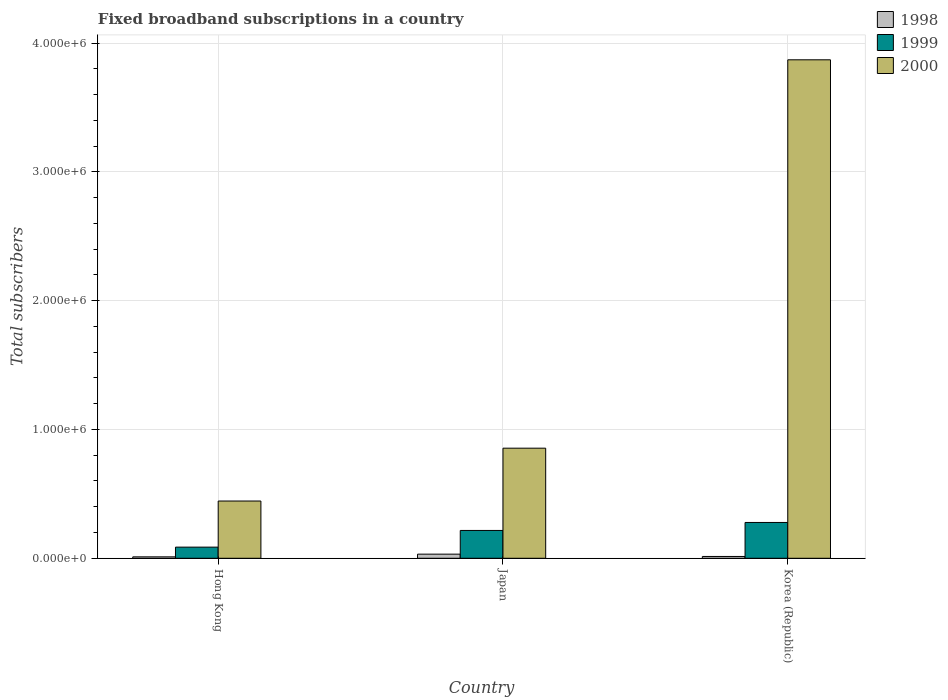How many different coloured bars are there?
Offer a very short reply. 3. Are the number of bars on each tick of the X-axis equal?
Provide a succinct answer. Yes. How many bars are there on the 2nd tick from the left?
Keep it short and to the point. 3. What is the label of the 2nd group of bars from the left?
Give a very brief answer. Japan. What is the number of broadband subscriptions in 1999 in Korea (Republic)?
Your answer should be very brief. 2.78e+05. Across all countries, what is the maximum number of broadband subscriptions in 1999?
Keep it short and to the point. 2.78e+05. Across all countries, what is the minimum number of broadband subscriptions in 2000?
Your answer should be compact. 4.44e+05. In which country was the number of broadband subscriptions in 1999 minimum?
Your answer should be very brief. Hong Kong. What is the total number of broadband subscriptions in 2000 in the graph?
Your answer should be very brief. 5.17e+06. What is the difference between the number of broadband subscriptions in 1999 in Hong Kong and that in Korea (Republic)?
Provide a short and direct response. -1.92e+05. What is the difference between the number of broadband subscriptions in 2000 in Japan and the number of broadband subscriptions in 1998 in Korea (Republic)?
Ensure brevity in your answer.  8.41e+05. What is the average number of broadband subscriptions in 2000 per country?
Provide a short and direct response. 1.72e+06. What is the difference between the number of broadband subscriptions of/in 1998 and number of broadband subscriptions of/in 1999 in Korea (Republic)?
Provide a succinct answer. -2.64e+05. In how many countries, is the number of broadband subscriptions in 1999 greater than 2200000?
Provide a succinct answer. 0. What is the ratio of the number of broadband subscriptions in 1999 in Hong Kong to that in Korea (Republic)?
Your answer should be very brief. 0.31. What is the difference between the highest and the second highest number of broadband subscriptions in 1999?
Your response must be concise. 1.92e+05. What is the difference between the highest and the lowest number of broadband subscriptions in 2000?
Make the answer very short. 3.43e+06. What does the 1st bar from the left in Korea (Republic) represents?
Give a very brief answer. 1998. How many bars are there?
Provide a short and direct response. 9. Are all the bars in the graph horizontal?
Your answer should be very brief. No. How many countries are there in the graph?
Your answer should be compact. 3. What is the difference between two consecutive major ticks on the Y-axis?
Offer a very short reply. 1.00e+06. Does the graph contain grids?
Keep it short and to the point. Yes. How many legend labels are there?
Your answer should be very brief. 3. What is the title of the graph?
Provide a short and direct response. Fixed broadband subscriptions in a country. Does "2010" appear as one of the legend labels in the graph?
Offer a very short reply. No. What is the label or title of the X-axis?
Ensure brevity in your answer.  Country. What is the label or title of the Y-axis?
Your response must be concise. Total subscribers. What is the Total subscribers in 1998 in Hong Kong?
Your answer should be compact. 1.10e+04. What is the Total subscribers of 1999 in Hong Kong?
Provide a succinct answer. 8.65e+04. What is the Total subscribers in 2000 in Hong Kong?
Give a very brief answer. 4.44e+05. What is the Total subscribers in 1998 in Japan?
Offer a terse response. 3.20e+04. What is the Total subscribers of 1999 in Japan?
Provide a short and direct response. 2.16e+05. What is the Total subscribers in 2000 in Japan?
Keep it short and to the point. 8.55e+05. What is the Total subscribers in 1998 in Korea (Republic)?
Ensure brevity in your answer.  1.40e+04. What is the Total subscribers in 1999 in Korea (Republic)?
Provide a succinct answer. 2.78e+05. What is the Total subscribers in 2000 in Korea (Republic)?
Offer a terse response. 3.87e+06. Across all countries, what is the maximum Total subscribers in 1998?
Keep it short and to the point. 3.20e+04. Across all countries, what is the maximum Total subscribers of 1999?
Provide a succinct answer. 2.78e+05. Across all countries, what is the maximum Total subscribers in 2000?
Offer a terse response. 3.87e+06. Across all countries, what is the minimum Total subscribers of 1998?
Offer a very short reply. 1.10e+04. Across all countries, what is the minimum Total subscribers in 1999?
Make the answer very short. 8.65e+04. Across all countries, what is the minimum Total subscribers in 2000?
Ensure brevity in your answer.  4.44e+05. What is the total Total subscribers in 1998 in the graph?
Your answer should be compact. 5.70e+04. What is the total Total subscribers of 1999 in the graph?
Make the answer very short. 5.80e+05. What is the total Total subscribers in 2000 in the graph?
Your answer should be very brief. 5.17e+06. What is the difference between the Total subscribers in 1998 in Hong Kong and that in Japan?
Your answer should be compact. -2.10e+04. What is the difference between the Total subscribers of 1999 in Hong Kong and that in Japan?
Your answer should be very brief. -1.30e+05. What is the difference between the Total subscribers of 2000 in Hong Kong and that in Japan?
Your response must be concise. -4.10e+05. What is the difference between the Total subscribers in 1998 in Hong Kong and that in Korea (Republic)?
Ensure brevity in your answer.  -3000. What is the difference between the Total subscribers of 1999 in Hong Kong and that in Korea (Republic)?
Your response must be concise. -1.92e+05. What is the difference between the Total subscribers of 2000 in Hong Kong and that in Korea (Republic)?
Provide a succinct answer. -3.43e+06. What is the difference between the Total subscribers in 1998 in Japan and that in Korea (Republic)?
Offer a very short reply. 1.80e+04. What is the difference between the Total subscribers in 1999 in Japan and that in Korea (Republic)?
Keep it short and to the point. -6.20e+04. What is the difference between the Total subscribers in 2000 in Japan and that in Korea (Republic)?
Give a very brief answer. -3.02e+06. What is the difference between the Total subscribers of 1998 in Hong Kong and the Total subscribers of 1999 in Japan?
Your response must be concise. -2.05e+05. What is the difference between the Total subscribers of 1998 in Hong Kong and the Total subscribers of 2000 in Japan?
Offer a very short reply. -8.44e+05. What is the difference between the Total subscribers in 1999 in Hong Kong and the Total subscribers in 2000 in Japan?
Provide a succinct answer. -7.68e+05. What is the difference between the Total subscribers in 1998 in Hong Kong and the Total subscribers in 1999 in Korea (Republic)?
Ensure brevity in your answer.  -2.67e+05. What is the difference between the Total subscribers of 1998 in Hong Kong and the Total subscribers of 2000 in Korea (Republic)?
Your answer should be very brief. -3.86e+06. What is the difference between the Total subscribers of 1999 in Hong Kong and the Total subscribers of 2000 in Korea (Republic)?
Provide a succinct answer. -3.78e+06. What is the difference between the Total subscribers in 1998 in Japan and the Total subscribers in 1999 in Korea (Republic)?
Ensure brevity in your answer.  -2.46e+05. What is the difference between the Total subscribers of 1998 in Japan and the Total subscribers of 2000 in Korea (Republic)?
Make the answer very short. -3.84e+06. What is the difference between the Total subscribers of 1999 in Japan and the Total subscribers of 2000 in Korea (Republic)?
Your answer should be compact. -3.65e+06. What is the average Total subscribers in 1998 per country?
Give a very brief answer. 1.90e+04. What is the average Total subscribers in 1999 per country?
Your response must be concise. 1.93e+05. What is the average Total subscribers in 2000 per country?
Your answer should be compact. 1.72e+06. What is the difference between the Total subscribers of 1998 and Total subscribers of 1999 in Hong Kong?
Offer a terse response. -7.55e+04. What is the difference between the Total subscribers of 1998 and Total subscribers of 2000 in Hong Kong?
Your answer should be very brief. -4.33e+05. What is the difference between the Total subscribers in 1999 and Total subscribers in 2000 in Hong Kong?
Keep it short and to the point. -3.58e+05. What is the difference between the Total subscribers in 1998 and Total subscribers in 1999 in Japan?
Ensure brevity in your answer.  -1.84e+05. What is the difference between the Total subscribers of 1998 and Total subscribers of 2000 in Japan?
Provide a short and direct response. -8.23e+05. What is the difference between the Total subscribers of 1999 and Total subscribers of 2000 in Japan?
Give a very brief answer. -6.39e+05. What is the difference between the Total subscribers of 1998 and Total subscribers of 1999 in Korea (Republic)?
Offer a terse response. -2.64e+05. What is the difference between the Total subscribers of 1998 and Total subscribers of 2000 in Korea (Republic)?
Your response must be concise. -3.86e+06. What is the difference between the Total subscribers in 1999 and Total subscribers in 2000 in Korea (Republic)?
Make the answer very short. -3.59e+06. What is the ratio of the Total subscribers in 1998 in Hong Kong to that in Japan?
Offer a very short reply. 0.34. What is the ratio of the Total subscribers in 1999 in Hong Kong to that in Japan?
Keep it short and to the point. 0.4. What is the ratio of the Total subscribers in 2000 in Hong Kong to that in Japan?
Ensure brevity in your answer.  0.52. What is the ratio of the Total subscribers in 1998 in Hong Kong to that in Korea (Republic)?
Ensure brevity in your answer.  0.79. What is the ratio of the Total subscribers in 1999 in Hong Kong to that in Korea (Republic)?
Your response must be concise. 0.31. What is the ratio of the Total subscribers in 2000 in Hong Kong to that in Korea (Republic)?
Ensure brevity in your answer.  0.11. What is the ratio of the Total subscribers in 1998 in Japan to that in Korea (Republic)?
Your response must be concise. 2.29. What is the ratio of the Total subscribers of 1999 in Japan to that in Korea (Republic)?
Provide a succinct answer. 0.78. What is the ratio of the Total subscribers of 2000 in Japan to that in Korea (Republic)?
Provide a short and direct response. 0.22. What is the difference between the highest and the second highest Total subscribers of 1998?
Ensure brevity in your answer.  1.80e+04. What is the difference between the highest and the second highest Total subscribers of 1999?
Keep it short and to the point. 6.20e+04. What is the difference between the highest and the second highest Total subscribers in 2000?
Give a very brief answer. 3.02e+06. What is the difference between the highest and the lowest Total subscribers of 1998?
Provide a succinct answer. 2.10e+04. What is the difference between the highest and the lowest Total subscribers of 1999?
Your response must be concise. 1.92e+05. What is the difference between the highest and the lowest Total subscribers of 2000?
Keep it short and to the point. 3.43e+06. 